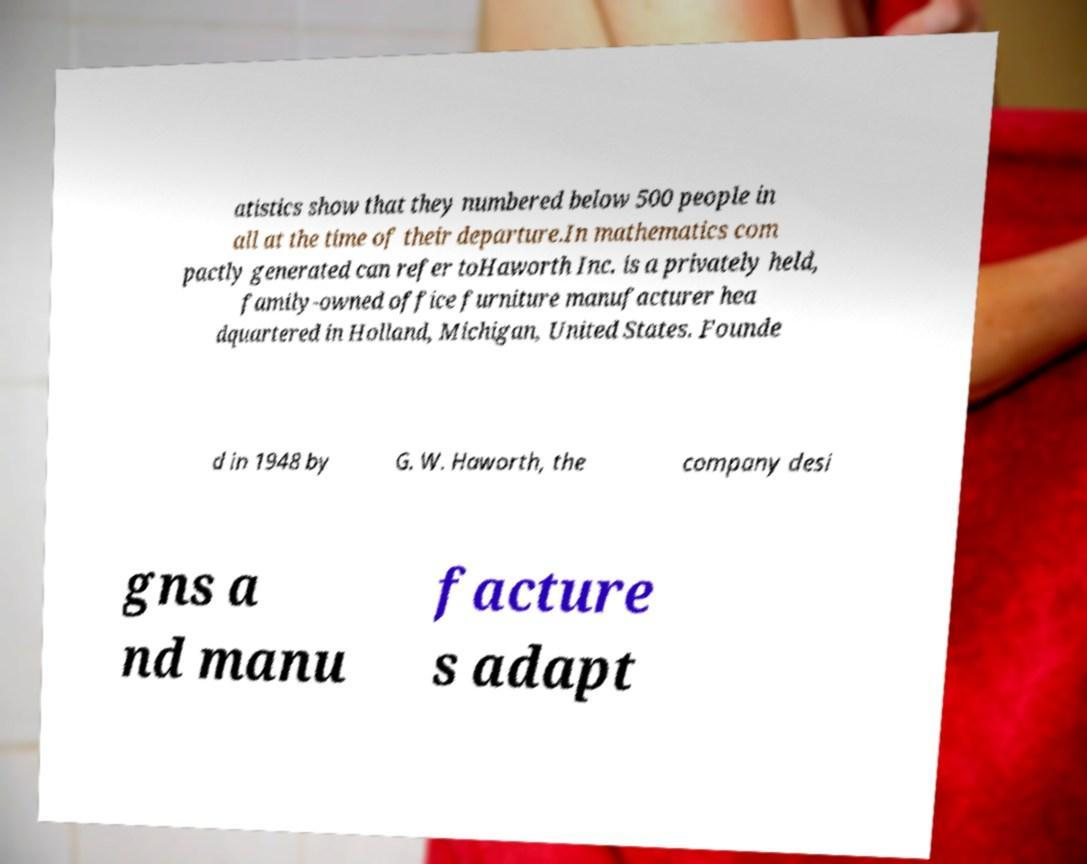Please read and relay the text visible in this image. What does it say? atistics show that they numbered below 500 people in all at the time of their departure.In mathematics com pactly generated can refer toHaworth Inc. is a privately held, family-owned office furniture manufacturer hea dquartered in Holland, Michigan, United States. Founde d in 1948 by G. W. Haworth, the company desi gns a nd manu facture s adapt 